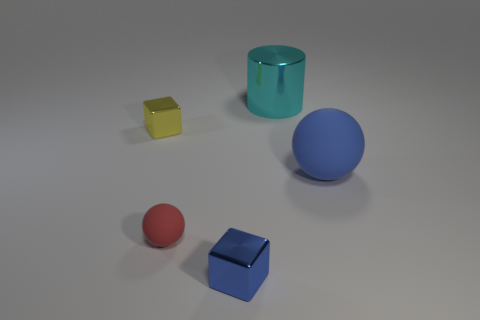What textures do the objects appear to have? The objects seem to have basic, untextured surfaces, likely made to appear as matte finishes, which don't reflect much light and have an even, non-glossy look. 